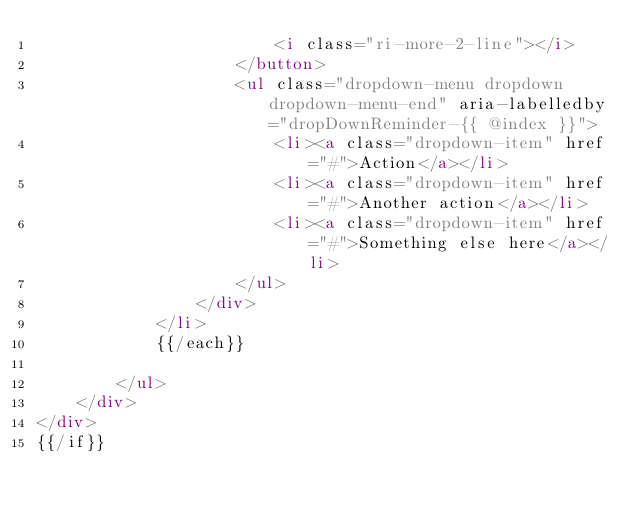<code> <loc_0><loc_0><loc_500><loc_500><_HTML_>                        <i class="ri-more-2-line"></i>
                    </button>
                    <ul class="dropdown-menu dropdown dropdown-menu-end" aria-labelledby="dropDownReminder-{{ @index }}">
                        <li><a class="dropdown-item" href="#">Action</a></li>
                        <li><a class="dropdown-item" href="#">Another action</a></li>
                        <li><a class="dropdown-item" href="#">Something else here</a></li>
                    </ul>
                </div>
            </li>
            {{/each}}

        </ul>
    </div>
</div>
{{/if}}</code> 